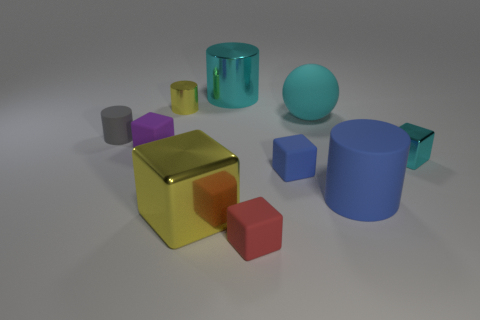Subtract all big cubes. How many cubes are left? 4 Subtract 1 blocks. How many blocks are left? 4 Subtract all yellow cylinders. How many cylinders are left? 3 Subtract 0 green blocks. How many objects are left? 10 Subtract all spheres. How many objects are left? 9 Subtract all yellow blocks. Subtract all green spheres. How many blocks are left? 4 Subtract all red balls. How many brown blocks are left? 0 Subtract all small red matte blocks. Subtract all cyan matte things. How many objects are left? 8 Add 6 small red rubber blocks. How many small red rubber blocks are left? 7 Add 5 blue cylinders. How many blue cylinders exist? 6 